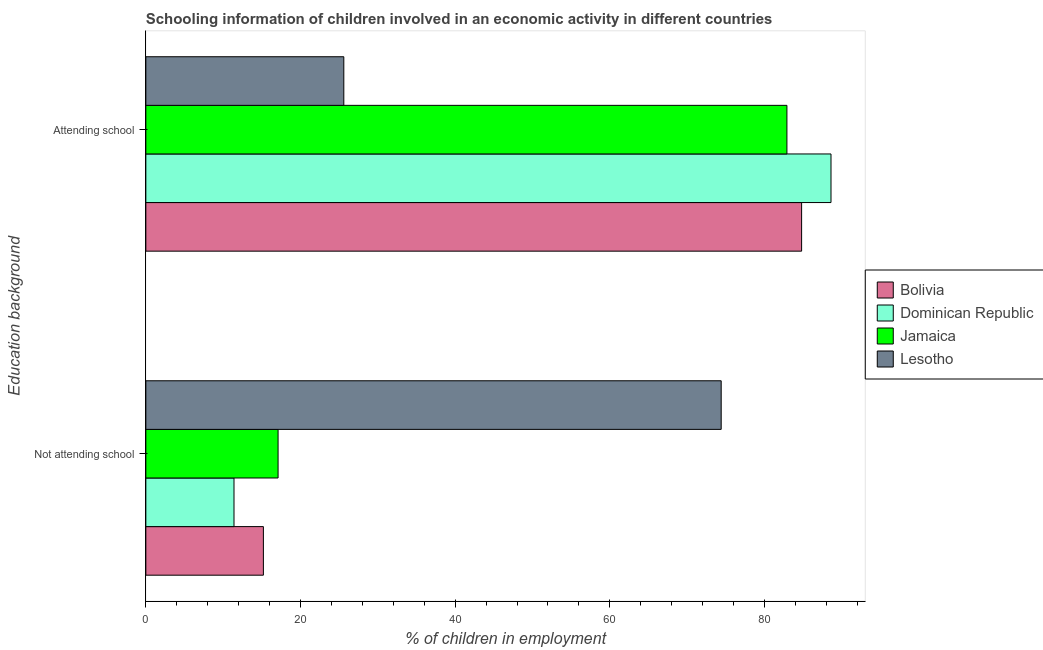Are the number of bars on each tick of the Y-axis equal?
Make the answer very short. Yes. What is the label of the 1st group of bars from the top?
Offer a terse response. Attending school. What is the percentage of employed children who are attending school in Jamaica?
Keep it short and to the point. 82.9. Across all countries, what is the maximum percentage of employed children who are attending school?
Offer a very short reply. 88.6. In which country was the percentage of employed children who are attending school maximum?
Ensure brevity in your answer.  Dominican Republic. In which country was the percentage of employed children who are attending school minimum?
Give a very brief answer. Lesotho. What is the total percentage of employed children who are attending school in the graph?
Give a very brief answer. 281.9. What is the difference between the percentage of employed children who are not attending school in Lesotho and that in Dominican Republic?
Provide a succinct answer. 63. What is the average percentage of employed children who are attending school per country?
Offer a terse response. 70.47. What is the difference between the percentage of employed children who are not attending school and percentage of employed children who are attending school in Lesotho?
Give a very brief answer. 48.8. In how many countries, is the percentage of employed children who are not attending school greater than 24 %?
Give a very brief answer. 1. What is the ratio of the percentage of employed children who are attending school in Jamaica to that in Bolivia?
Your answer should be very brief. 0.98. Is the percentage of employed children who are attending school in Bolivia less than that in Dominican Republic?
Keep it short and to the point. Yes. What does the 4th bar from the bottom in Not attending school represents?
Keep it short and to the point. Lesotho. How many bars are there?
Provide a succinct answer. 8. What is the difference between two consecutive major ticks on the X-axis?
Your answer should be very brief. 20. Are the values on the major ticks of X-axis written in scientific E-notation?
Ensure brevity in your answer.  No. Does the graph contain grids?
Make the answer very short. No. What is the title of the graph?
Your response must be concise. Schooling information of children involved in an economic activity in different countries. What is the label or title of the X-axis?
Offer a very short reply. % of children in employment. What is the label or title of the Y-axis?
Provide a succinct answer. Education background. What is the % of children in employment of Dominican Republic in Not attending school?
Give a very brief answer. 11.4. What is the % of children in employment in Jamaica in Not attending school?
Your answer should be compact. 17.1. What is the % of children in employment in Lesotho in Not attending school?
Ensure brevity in your answer.  74.4. What is the % of children in employment in Bolivia in Attending school?
Your answer should be very brief. 84.8. What is the % of children in employment of Dominican Republic in Attending school?
Your response must be concise. 88.6. What is the % of children in employment of Jamaica in Attending school?
Make the answer very short. 82.9. What is the % of children in employment in Lesotho in Attending school?
Give a very brief answer. 25.6. Across all Education background, what is the maximum % of children in employment in Bolivia?
Your answer should be very brief. 84.8. Across all Education background, what is the maximum % of children in employment of Dominican Republic?
Provide a short and direct response. 88.6. Across all Education background, what is the maximum % of children in employment of Jamaica?
Offer a terse response. 82.9. Across all Education background, what is the maximum % of children in employment of Lesotho?
Keep it short and to the point. 74.4. Across all Education background, what is the minimum % of children in employment of Jamaica?
Keep it short and to the point. 17.1. Across all Education background, what is the minimum % of children in employment in Lesotho?
Your answer should be compact. 25.6. What is the total % of children in employment in Dominican Republic in the graph?
Give a very brief answer. 100. What is the total % of children in employment in Lesotho in the graph?
Provide a short and direct response. 100. What is the difference between the % of children in employment of Bolivia in Not attending school and that in Attending school?
Provide a succinct answer. -69.6. What is the difference between the % of children in employment in Dominican Republic in Not attending school and that in Attending school?
Make the answer very short. -77.2. What is the difference between the % of children in employment in Jamaica in Not attending school and that in Attending school?
Provide a short and direct response. -65.8. What is the difference between the % of children in employment of Lesotho in Not attending school and that in Attending school?
Give a very brief answer. 48.8. What is the difference between the % of children in employment in Bolivia in Not attending school and the % of children in employment in Dominican Republic in Attending school?
Provide a short and direct response. -73.4. What is the difference between the % of children in employment in Bolivia in Not attending school and the % of children in employment in Jamaica in Attending school?
Offer a terse response. -67.7. What is the difference between the % of children in employment in Dominican Republic in Not attending school and the % of children in employment in Jamaica in Attending school?
Give a very brief answer. -71.5. What is the average % of children in employment in Dominican Republic per Education background?
Provide a succinct answer. 50. What is the difference between the % of children in employment in Bolivia and % of children in employment in Dominican Republic in Not attending school?
Offer a terse response. 3.8. What is the difference between the % of children in employment of Bolivia and % of children in employment of Jamaica in Not attending school?
Your response must be concise. -1.9. What is the difference between the % of children in employment in Bolivia and % of children in employment in Lesotho in Not attending school?
Offer a terse response. -59.2. What is the difference between the % of children in employment in Dominican Republic and % of children in employment in Lesotho in Not attending school?
Give a very brief answer. -63. What is the difference between the % of children in employment of Jamaica and % of children in employment of Lesotho in Not attending school?
Ensure brevity in your answer.  -57.3. What is the difference between the % of children in employment of Bolivia and % of children in employment of Dominican Republic in Attending school?
Ensure brevity in your answer.  -3.8. What is the difference between the % of children in employment of Bolivia and % of children in employment of Lesotho in Attending school?
Give a very brief answer. 59.2. What is the difference between the % of children in employment in Jamaica and % of children in employment in Lesotho in Attending school?
Keep it short and to the point. 57.3. What is the ratio of the % of children in employment of Bolivia in Not attending school to that in Attending school?
Your answer should be very brief. 0.18. What is the ratio of the % of children in employment in Dominican Republic in Not attending school to that in Attending school?
Your answer should be very brief. 0.13. What is the ratio of the % of children in employment of Jamaica in Not attending school to that in Attending school?
Provide a succinct answer. 0.21. What is the ratio of the % of children in employment in Lesotho in Not attending school to that in Attending school?
Keep it short and to the point. 2.91. What is the difference between the highest and the second highest % of children in employment of Bolivia?
Your response must be concise. 69.6. What is the difference between the highest and the second highest % of children in employment of Dominican Republic?
Your response must be concise. 77.2. What is the difference between the highest and the second highest % of children in employment of Jamaica?
Provide a succinct answer. 65.8. What is the difference between the highest and the second highest % of children in employment in Lesotho?
Provide a succinct answer. 48.8. What is the difference between the highest and the lowest % of children in employment of Bolivia?
Your answer should be very brief. 69.6. What is the difference between the highest and the lowest % of children in employment of Dominican Republic?
Provide a short and direct response. 77.2. What is the difference between the highest and the lowest % of children in employment of Jamaica?
Make the answer very short. 65.8. What is the difference between the highest and the lowest % of children in employment of Lesotho?
Give a very brief answer. 48.8. 